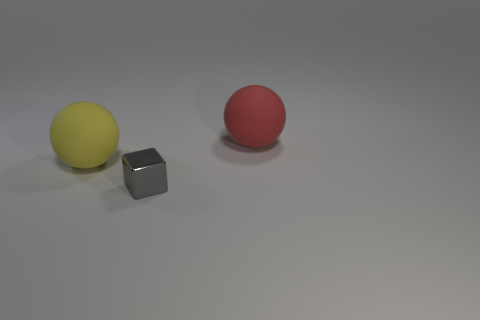Are there any other things that are the same size as the gray shiny thing?
Provide a short and direct response. No. What is the size of the other object that is the same shape as the big red object?
Your response must be concise. Large. Are there any other things that are made of the same material as the block?
Ensure brevity in your answer.  No. Is there a small purple rubber cylinder?
Ensure brevity in your answer.  No. Do the small metal cube and the large sphere to the right of the large yellow sphere have the same color?
Your response must be concise. No. What size is the cube that is on the left side of the sphere to the right of the big rubber ball in front of the large red ball?
Your answer should be compact. Small. How many things are small metal cubes or objects that are behind the tiny cube?
Offer a very short reply. 3. What color is the tiny block?
Your response must be concise. Gray. There is a sphere that is in front of the large red rubber sphere; what color is it?
Give a very brief answer. Yellow. What number of yellow matte things are in front of the big thing left of the tiny metallic block?
Give a very brief answer. 0. 